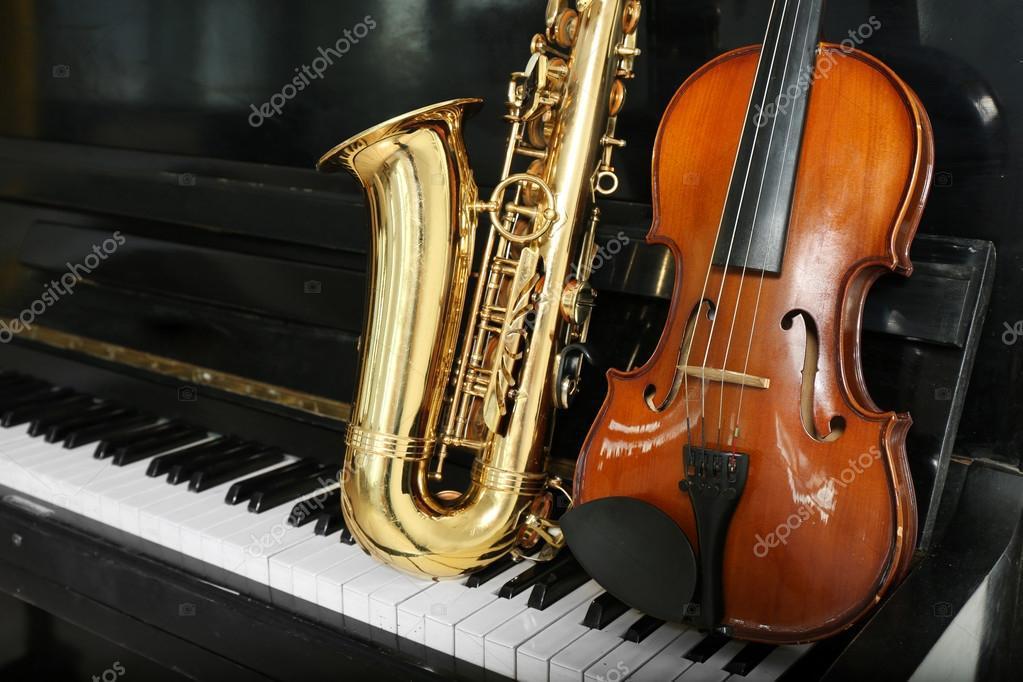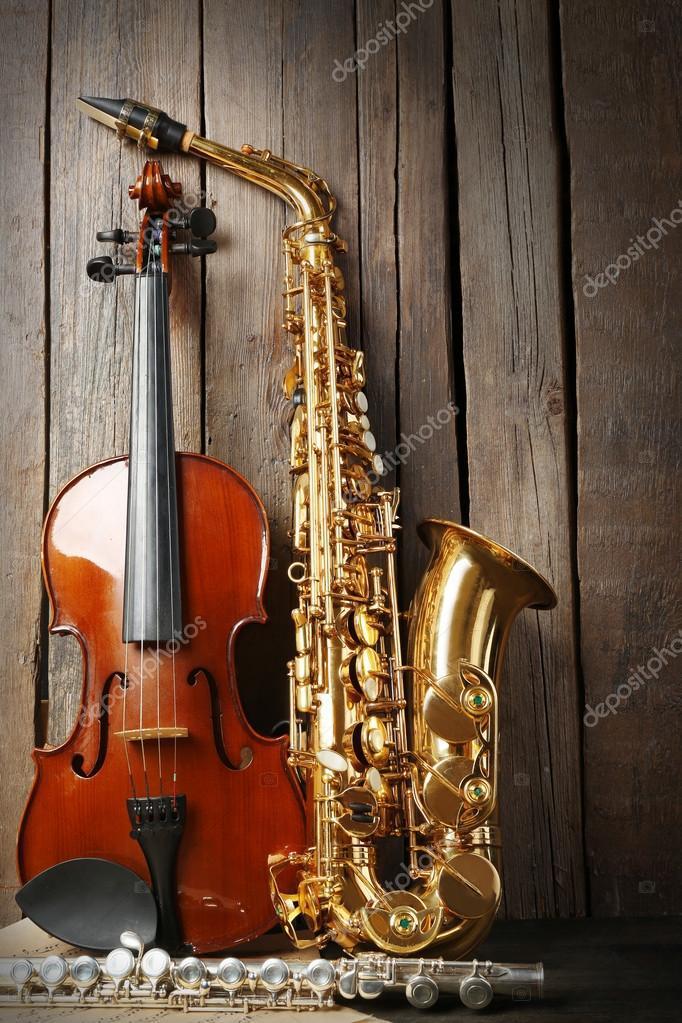The first image is the image on the left, the second image is the image on the right. Examine the images to the left and right. Is the description "A violin is next to a saxophone in each image." accurate? Answer yes or no. Yes. The first image is the image on the left, the second image is the image on the right. Examine the images to the left and right. Is the description "Both images contain three instruments." accurate? Answer yes or no. Yes. 